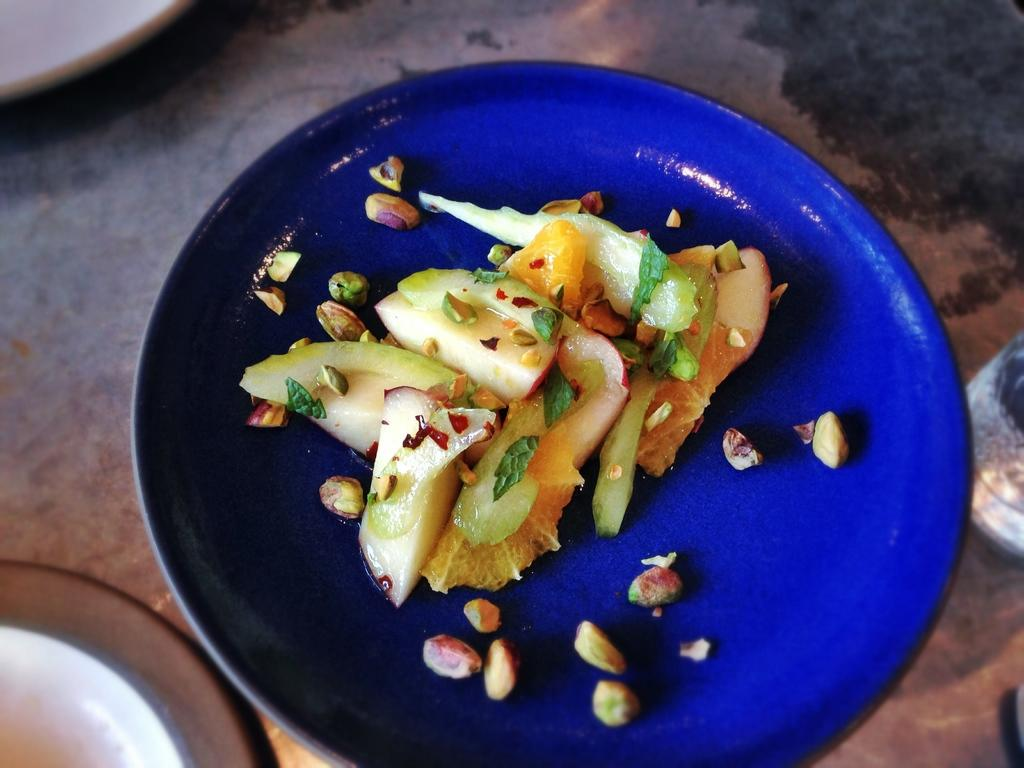What color is the plate in the image? The plate in the image is blue colored. What is on the plate? There is a food item on the plate. Can you describe the colors of the food item? The food item has cream, green, and orange colors. Are there any other colors present in the image? Yes, there are other places in the image that are white in color. Can you tell me how many basketballs are visible in the image? There are no basketballs present in the image. Is there a gun visible in the image? There is no gun present in the image. 